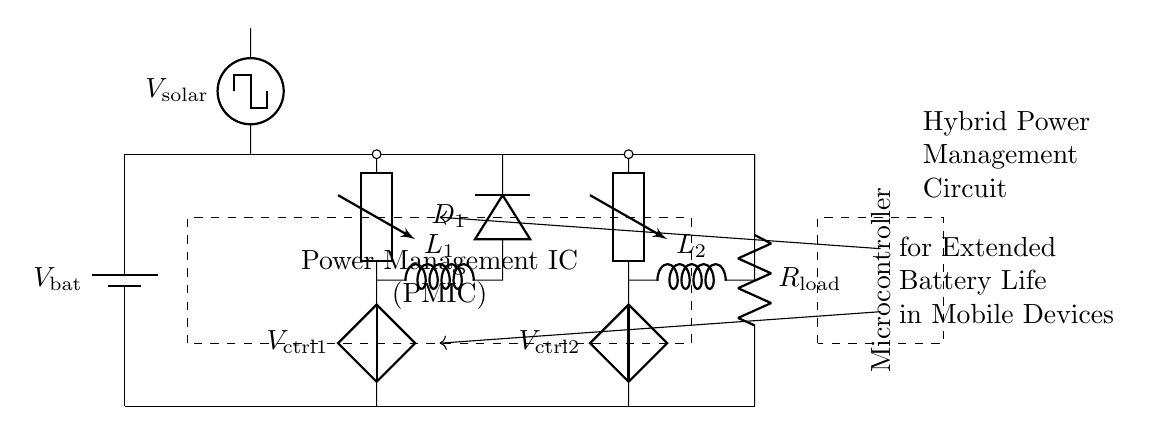what type of circuit is shown? The circuit is a hybrid power management circuit, as indicated in the label. The combination of solar and battery power sources is typical of hybrid designs.
Answer: hybrid power management circuit what components are used for voltage conversion? The circuit includes a boost converter and a buck converter for voltage conversion. The boost converter increases voltage, while the buck converter decreases voltage.
Answer: boost converter and buck converter what is the purpose of the PMIC? The Power Management IC (PMIC) coordinates the operation of different power sources and manages output to the load effectively. It is essential in hybrid power management for optimizing battery life.
Answer: optimize battery life how many inductors are present in the circuit? There are two inductors, denoted as L1 and L2, used in the boost and buck converters respectively.
Answer: 2 what does V solar represent? V solar represents the voltage output from the solar cell, which contributes to charging the battery or supplying power directly to the load.
Answer: the voltage output from the solar cell which component provides power to the load? The load is powered directly by the main power bus, which receives energy from both the battery and the buck converter outputs.
Answer: main power bus what type of control signals does the microcontroller send? The microcontroller sends control signals to manage the operation of the boost and buck converters, typically adjusting their duty cycles based on load requirements.
Answer: manage boost and buck converters 